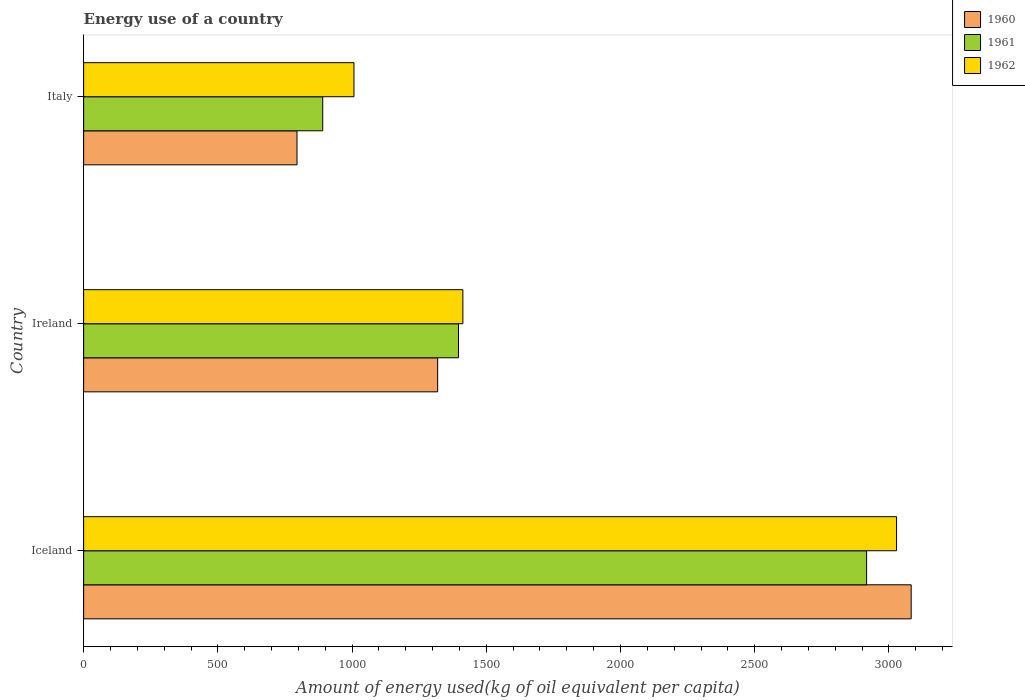Are the number of bars per tick equal to the number of legend labels?
Offer a very short reply. Yes. Are the number of bars on each tick of the Y-axis equal?
Provide a short and direct response. Yes. What is the label of the 3rd group of bars from the top?
Make the answer very short. Iceland. In how many cases, is the number of bars for a given country not equal to the number of legend labels?
Offer a very short reply. 0. What is the amount of energy used in in 1960 in Italy?
Provide a short and direct response. 794.82. Across all countries, what is the maximum amount of energy used in in 1961?
Give a very brief answer. 2916.71. Across all countries, what is the minimum amount of energy used in in 1960?
Offer a terse response. 794.82. What is the total amount of energy used in in 1962 in the graph?
Offer a terse response. 5448.08. What is the difference between the amount of energy used in in 1961 in Iceland and that in Ireland?
Keep it short and to the point. 1520.24. What is the difference between the amount of energy used in in 1961 in Italy and the amount of energy used in in 1962 in Ireland?
Provide a short and direct response. -522.04. What is the average amount of energy used in in 1960 per country?
Your response must be concise. 1732.11. What is the difference between the amount of energy used in in 1960 and amount of energy used in in 1961 in Italy?
Provide a short and direct response. -95.87. In how many countries, is the amount of energy used in in 1961 greater than 1300 kg?
Your answer should be very brief. 2. What is the ratio of the amount of energy used in in 1960 in Iceland to that in Italy?
Offer a very short reply. 3.88. Is the amount of energy used in in 1960 in Iceland less than that in Ireland?
Provide a succinct answer. No. What is the difference between the highest and the second highest amount of energy used in in 1961?
Keep it short and to the point. 1520.24. What is the difference between the highest and the lowest amount of energy used in in 1960?
Ensure brevity in your answer.  2287.9. In how many countries, is the amount of energy used in in 1962 greater than the average amount of energy used in in 1962 taken over all countries?
Your answer should be very brief. 1. What does the 2nd bar from the top in Iceland represents?
Provide a succinct answer. 1961. Is it the case that in every country, the sum of the amount of energy used in in 1961 and amount of energy used in in 1960 is greater than the amount of energy used in in 1962?
Your answer should be very brief. Yes. Are all the bars in the graph horizontal?
Offer a very short reply. Yes. Does the graph contain grids?
Provide a succinct answer. No. Where does the legend appear in the graph?
Provide a succinct answer. Top right. What is the title of the graph?
Your answer should be very brief. Energy use of a country. Does "1962" appear as one of the legend labels in the graph?
Provide a succinct answer. Yes. What is the label or title of the X-axis?
Your answer should be very brief. Amount of energy used(kg of oil equivalent per capita). What is the label or title of the Y-axis?
Keep it short and to the point. Country. What is the Amount of energy used(kg of oil equivalent per capita) of 1960 in Iceland?
Your answer should be very brief. 3082.71. What is the Amount of energy used(kg of oil equivalent per capita) in 1961 in Iceland?
Ensure brevity in your answer.  2916.71. What is the Amount of energy used(kg of oil equivalent per capita) in 1962 in Iceland?
Offer a terse response. 3028.3. What is the Amount of energy used(kg of oil equivalent per capita) of 1960 in Ireland?
Provide a succinct answer. 1318.81. What is the Amount of energy used(kg of oil equivalent per capita) of 1961 in Ireland?
Provide a succinct answer. 1396.47. What is the Amount of energy used(kg of oil equivalent per capita) of 1962 in Ireland?
Make the answer very short. 1412.73. What is the Amount of energy used(kg of oil equivalent per capita) in 1960 in Italy?
Your response must be concise. 794.82. What is the Amount of energy used(kg of oil equivalent per capita) of 1961 in Italy?
Offer a terse response. 890.69. What is the Amount of energy used(kg of oil equivalent per capita) in 1962 in Italy?
Provide a succinct answer. 1007.05. Across all countries, what is the maximum Amount of energy used(kg of oil equivalent per capita) of 1960?
Ensure brevity in your answer.  3082.71. Across all countries, what is the maximum Amount of energy used(kg of oil equivalent per capita) in 1961?
Offer a terse response. 2916.71. Across all countries, what is the maximum Amount of energy used(kg of oil equivalent per capita) in 1962?
Offer a terse response. 3028.3. Across all countries, what is the minimum Amount of energy used(kg of oil equivalent per capita) of 1960?
Ensure brevity in your answer.  794.82. Across all countries, what is the minimum Amount of energy used(kg of oil equivalent per capita) in 1961?
Offer a very short reply. 890.69. Across all countries, what is the minimum Amount of energy used(kg of oil equivalent per capita) of 1962?
Offer a terse response. 1007.05. What is the total Amount of energy used(kg of oil equivalent per capita) of 1960 in the graph?
Your answer should be compact. 5196.34. What is the total Amount of energy used(kg of oil equivalent per capita) in 1961 in the graph?
Provide a succinct answer. 5203.86. What is the total Amount of energy used(kg of oil equivalent per capita) of 1962 in the graph?
Provide a succinct answer. 5448.08. What is the difference between the Amount of energy used(kg of oil equivalent per capita) in 1960 in Iceland and that in Ireland?
Your answer should be compact. 1763.9. What is the difference between the Amount of energy used(kg of oil equivalent per capita) in 1961 in Iceland and that in Ireland?
Make the answer very short. 1520.24. What is the difference between the Amount of energy used(kg of oil equivalent per capita) in 1962 in Iceland and that in Ireland?
Offer a very short reply. 1615.57. What is the difference between the Amount of energy used(kg of oil equivalent per capita) in 1960 in Iceland and that in Italy?
Provide a short and direct response. 2287.9. What is the difference between the Amount of energy used(kg of oil equivalent per capita) of 1961 in Iceland and that in Italy?
Your answer should be very brief. 2026.02. What is the difference between the Amount of energy used(kg of oil equivalent per capita) in 1962 in Iceland and that in Italy?
Ensure brevity in your answer.  2021.25. What is the difference between the Amount of energy used(kg of oil equivalent per capita) in 1960 in Ireland and that in Italy?
Give a very brief answer. 524. What is the difference between the Amount of energy used(kg of oil equivalent per capita) of 1961 in Ireland and that in Italy?
Your response must be concise. 505.78. What is the difference between the Amount of energy used(kg of oil equivalent per capita) of 1962 in Ireland and that in Italy?
Provide a succinct answer. 405.68. What is the difference between the Amount of energy used(kg of oil equivalent per capita) of 1960 in Iceland and the Amount of energy used(kg of oil equivalent per capita) of 1961 in Ireland?
Ensure brevity in your answer.  1686.25. What is the difference between the Amount of energy used(kg of oil equivalent per capita) in 1960 in Iceland and the Amount of energy used(kg of oil equivalent per capita) in 1962 in Ireland?
Make the answer very short. 1669.98. What is the difference between the Amount of energy used(kg of oil equivalent per capita) of 1961 in Iceland and the Amount of energy used(kg of oil equivalent per capita) of 1962 in Ireland?
Ensure brevity in your answer.  1503.98. What is the difference between the Amount of energy used(kg of oil equivalent per capita) in 1960 in Iceland and the Amount of energy used(kg of oil equivalent per capita) in 1961 in Italy?
Offer a very short reply. 2192.02. What is the difference between the Amount of energy used(kg of oil equivalent per capita) of 1960 in Iceland and the Amount of energy used(kg of oil equivalent per capita) of 1962 in Italy?
Keep it short and to the point. 2075.66. What is the difference between the Amount of energy used(kg of oil equivalent per capita) of 1961 in Iceland and the Amount of energy used(kg of oil equivalent per capita) of 1962 in Italy?
Make the answer very short. 1909.66. What is the difference between the Amount of energy used(kg of oil equivalent per capita) in 1960 in Ireland and the Amount of energy used(kg of oil equivalent per capita) in 1961 in Italy?
Make the answer very short. 428.12. What is the difference between the Amount of energy used(kg of oil equivalent per capita) of 1960 in Ireland and the Amount of energy used(kg of oil equivalent per capita) of 1962 in Italy?
Keep it short and to the point. 311.76. What is the difference between the Amount of energy used(kg of oil equivalent per capita) of 1961 in Ireland and the Amount of energy used(kg of oil equivalent per capita) of 1962 in Italy?
Give a very brief answer. 389.42. What is the average Amount of energy used(kg of oil equivalent per capita) of 1960 per country?
Offer a very short reply. 1732.11. What is the average Amount of energy used(kg of oil equivalent per capita) of 1961 per country?
Give a very brief answer. 1734.62. What is the average Amount of energy used(kg of oil equivalent per capita) in 1962 per country?
Your answer should be very brief. 1816.03. What is the difference between the Amount of energy used(kg of oil equivalent per capita) in 1960 and Amount of energy used(kg of oil equivalent per capita) in 1961 in Iceland?
Your answer should be very brief. 166.01. What is the difference between the Amount of energy used(kg of oil equivalent per capita) in 1960 and Amount of energy used(kg of oil equivalent per capita) in 1962 in Iceland?
Keep it short and to the point. 54.41. What is the difference between the Amount of energy used(kg of oil equivalent per capita) of 1961 and Amount of energy used(kg of oil equivalent per capita) of 1962 in Iceland?
Give a very brief answer. -111.59. What is the difference between the Amount of energy used(kg of oil equivalent per capita) of 1960 and Amount of energy used(kg of oil equivalent per capita) of 1961 in Ireland?
Provide a short and direct response. -77.65. What is the difference between the Amount of energy used(kg of oil equivalent per capita) of 1960 and Amount of energy used(kg of oil equivalent per capita) of 1962 in Ireland?
Offer a terse response. -93.92. What is the difference between the Amount of energy used(kg of oil equivalent per capita) of 1961 and Amount of energy used(kg of oil equivalent per capita) of 1962 in Ireland?
Make the answer very short. -16.26. What is the difference between the Amount of energy used(kg of oil equivalent per capita) in 1960 and Amount of energy used(kg of oil equivalent per capita) in 1961 in Italy?
Your response must be concise. -95.87. What is the difference between the Amount of energy used(kg of oil equivalent per capita) in 1960 and Amount of energy used(kg of oil equivalent per capita) in 1962 in Italy?
Provide a short and direct response. -212.23. What is the difference between the Amount of energy used(kg of oil equivalent per capita) in 1961 and Amount of energy used(kg of oil equivalent per capita) in 1962 in Italy?
Offer a terse response. -116.36. What is the ratio of the Amount of energy used(kg of oil equivalent per capita) in 1960 in Iceland to that in Ireland?
Offer a terse response. 2.34. What is the ratio of the Amount of energy used(kg of oil equivalent per capita) in 1961 in Iceland to that in Ireland?
Offer a terse response. 2.09. What is the ratio of the Amount of energy used(kg of oil equivalent per capita) in 1962 in Iceland to that in Ireland?
Offer a terse response. 2.14. What is the ratio of the Amount of energy used(kg of oil equivalent per capita) in 1960 in Iceland to that in Italy?
Provide a succinct answer. 3.88. What is the ratio of the Amount of energy used(kg of oil equivalent per capita) in 1961 in Iceland to that in Italy?
Make the answer very short. 3.27. What is the ratio of the Amount of energy used(kg of oil equivalent per capita) of 1962 in Iceland to that in Italy?
Make the answer very short. 3.01. What is the ratio of the Amount of energy used(kg of oil equivalent per capita) of 1960 in Ireland to that in Italy?
Keep it short and to the point. 1.66. What is the ratio of the Amount of energy used(kg of oil equivalent per capita) of 1961 in Ireland to that in Italy?
Your answer should be very brief. 1.57. What is the ratio of the Amount of energy used(kg of oil equivalent per capita) in 1962 in Ireland to that in Italy?
Ensure brevity in your answer.  1.4. What is the difference between the highest and the second highest Amount of energy used(kg of oil equivalent per capita) of 1960?
Offer a very short reply. 1763.9. What is the difference between the highest and the second highest Amount of energy used(kg of oil equivalent per capita) in 1961?
Make the answer very short. 1520.24. What is the difference between the highest and the second highest Amount of energy used(kg of oil equivalent per capita) of 1962?
Your answer should be very brief. 1615.57. What is the difference between the highest and the lowest Amount of energy used(kg of oil equivalent per capita) of 1960?
Your answer should be very brief. 2287.9. What is the difference between the highest and the lowest Amount of energy used(kg of oil equivalent per capita) of 1961?
Your answer should be compact. 2026.02. What is the difference between the highest and the lowest Amount of energy used(kg of oil equivalent per capita) of 1962?
Your answer should be compact. 2021.25. 